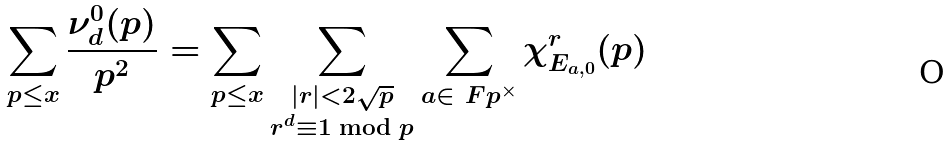Convert formula to latex. <formula><loc_0><loc_0><loc_500><loc_500>\sum _ { p \leq x } \frac { \nu ^ { 0 } _ { d } ( p ) } { p ^ { 2 } } & = \sum _ { p \leq x } \sum _ { \substack { | r | < 2 \sqrt { p } \\ r ^ { d } \equiv 1 \bmod { p } } } \sum _ { a \in \ F p ^ { \times } } \chi _ { E _ { a , 0 } } ^ { r } ( p )</formula> 